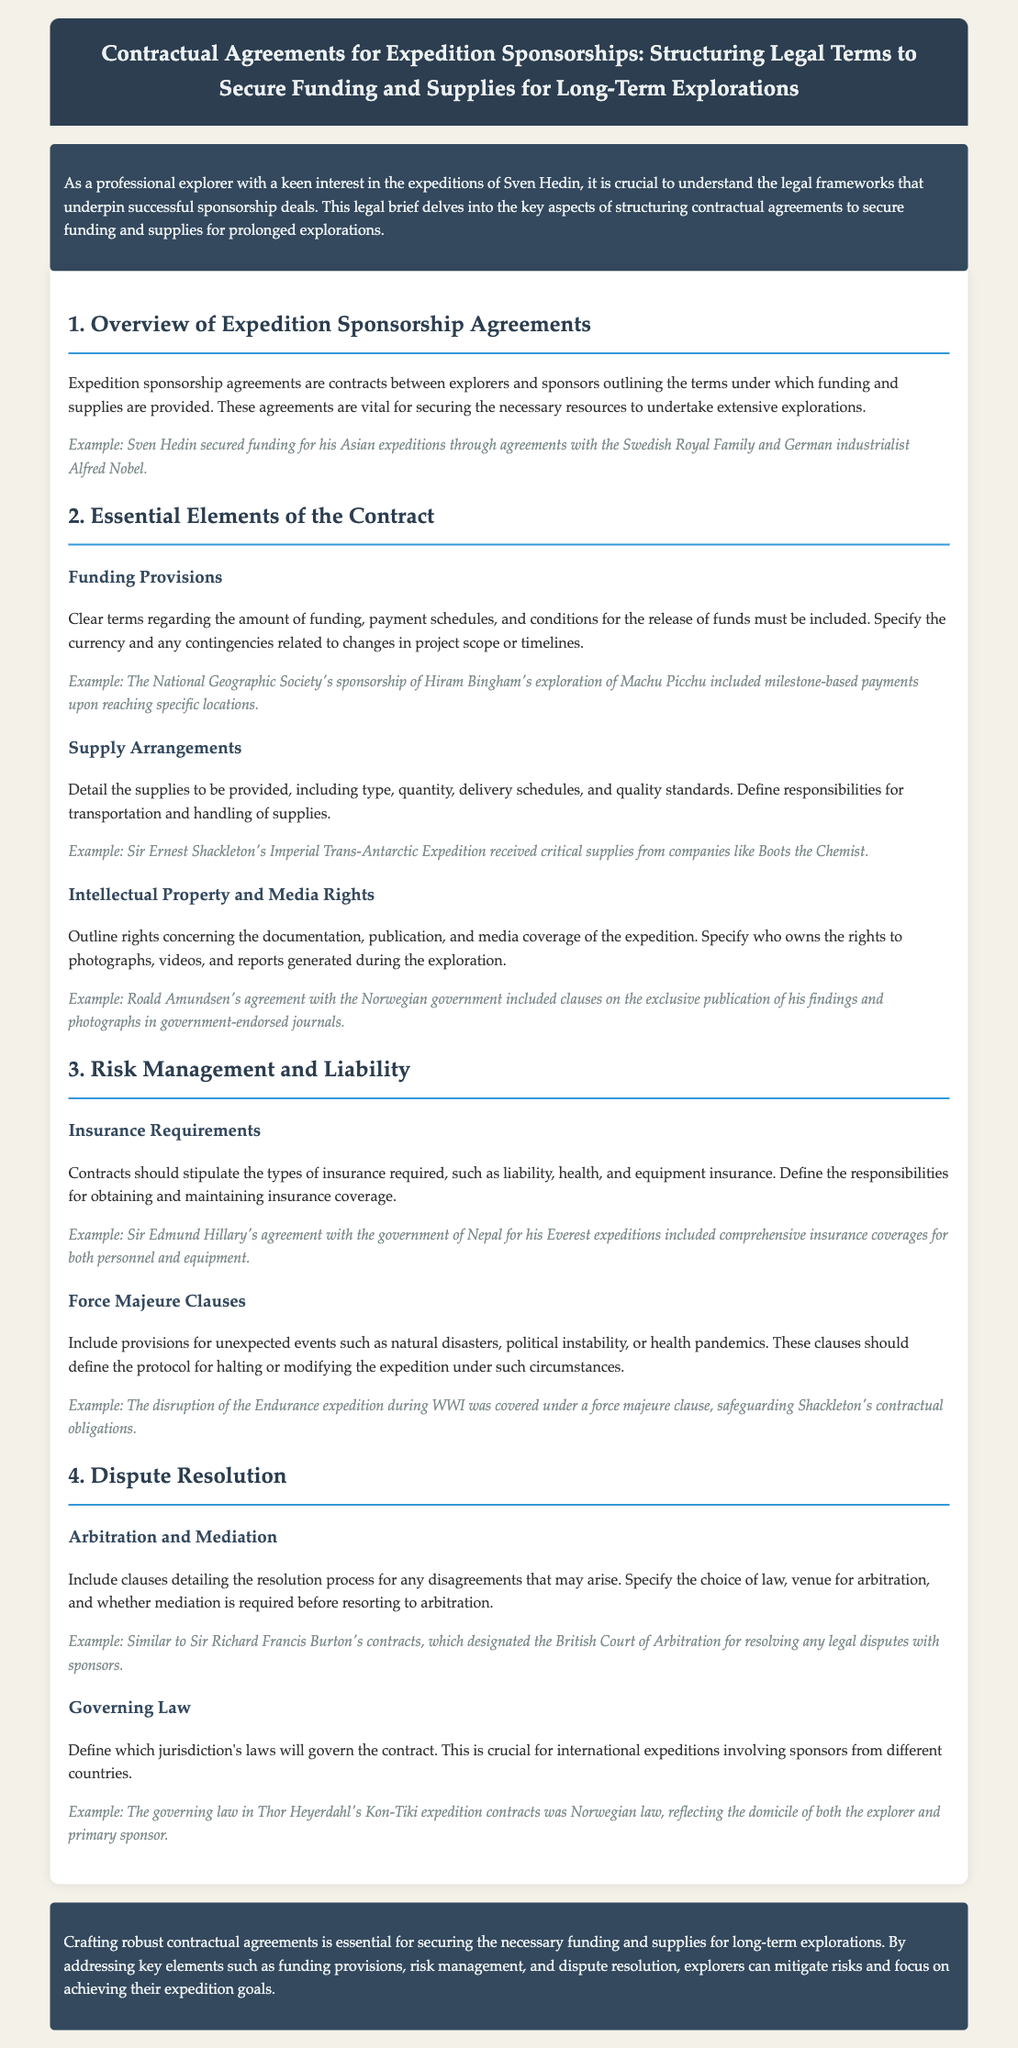What is the title of the document? The title summarizes the content and is found at the top of the document.
Answer: Contractual Agreements for Expedition Sponsorships: Structuring Legal Terms to Secure Funding and Supplies for Long-Term Explorations Who are some historical figures mentioned in the example sponsorship agreements? The document provides examples of various explorers who secured funding through sponsorship agreements.
Answer: Sven Hedin, Alfred Nobel, Hiram Bingham, Sir Ernest Shackleton, Roald Amundsen, Sir Edmund Hillary, Thor Heyerdahl What is included under Funding Provisions? Funding Provisions detail specific financial aspects that need to be clarified in the contract.
Answer: Amount of funding, payment schedules, conditions for the release of funds What type of insurance is required in contracts? The document outlines specific insurance types that are crucial for expedition contracts to mitigate risks.
Answer: Liability, health, and equipment insurance What does the force majeure clause address? This clause is critical in contracts to provide guidance in unexpected, uncontrollable events.
Answer: Unexpected events such as natural disasters, political instability, or health pandemics What method is suggested for resolving disputes in the agreement? The document discusses methods to handle disagreements that arise during the sponsorship.
Answer: Arbitration and Mediation What does the governing law clause specify? The governing law clause clarifies which jurisdiction's laws will be applicable for the contract.
Answer: Jurisdiction's laws governing the contract Which organization sponsored Hiram Bingham's exploration? This sponsorship is noted in an example demonstrating historical funding arrangements.
Answer: National Geographic Society 